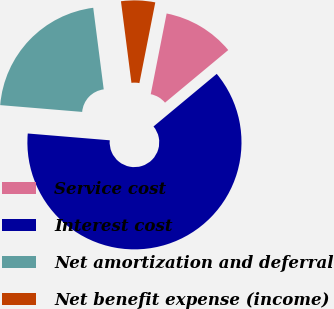Convert chart. <chart><loc_0><loc_0><loc_500><loc_500><pie_chart><fcel>Service cost<fcel>Interest cost<fcel>Net amortization and deferral<fcel>Net benefit expense (income)<nl><fcel>10.86%<fcel>62.36%<fcel>21.65%<fcel>5.13%<nl></chart> 